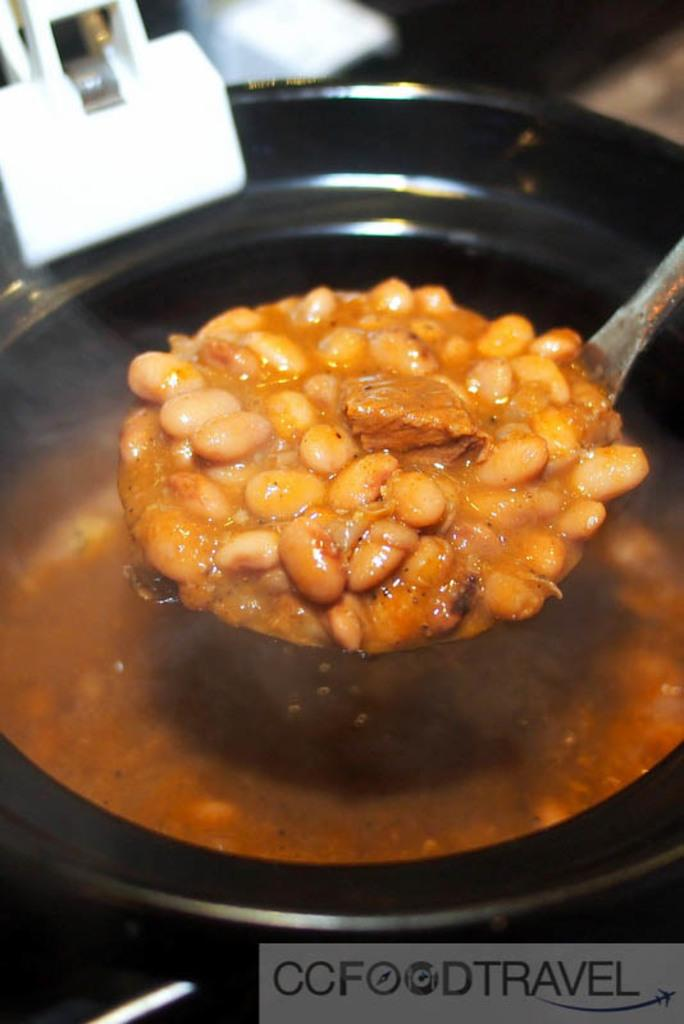What is in the bowl that is visible in the image? There is a bowl full of soup in the image. What utensil is present in the image? There is a spoon with some food in the image. What type of parent can be seen in the image? There is no parent present in the image; it only features a bowl of soup and a spoon with some food. 